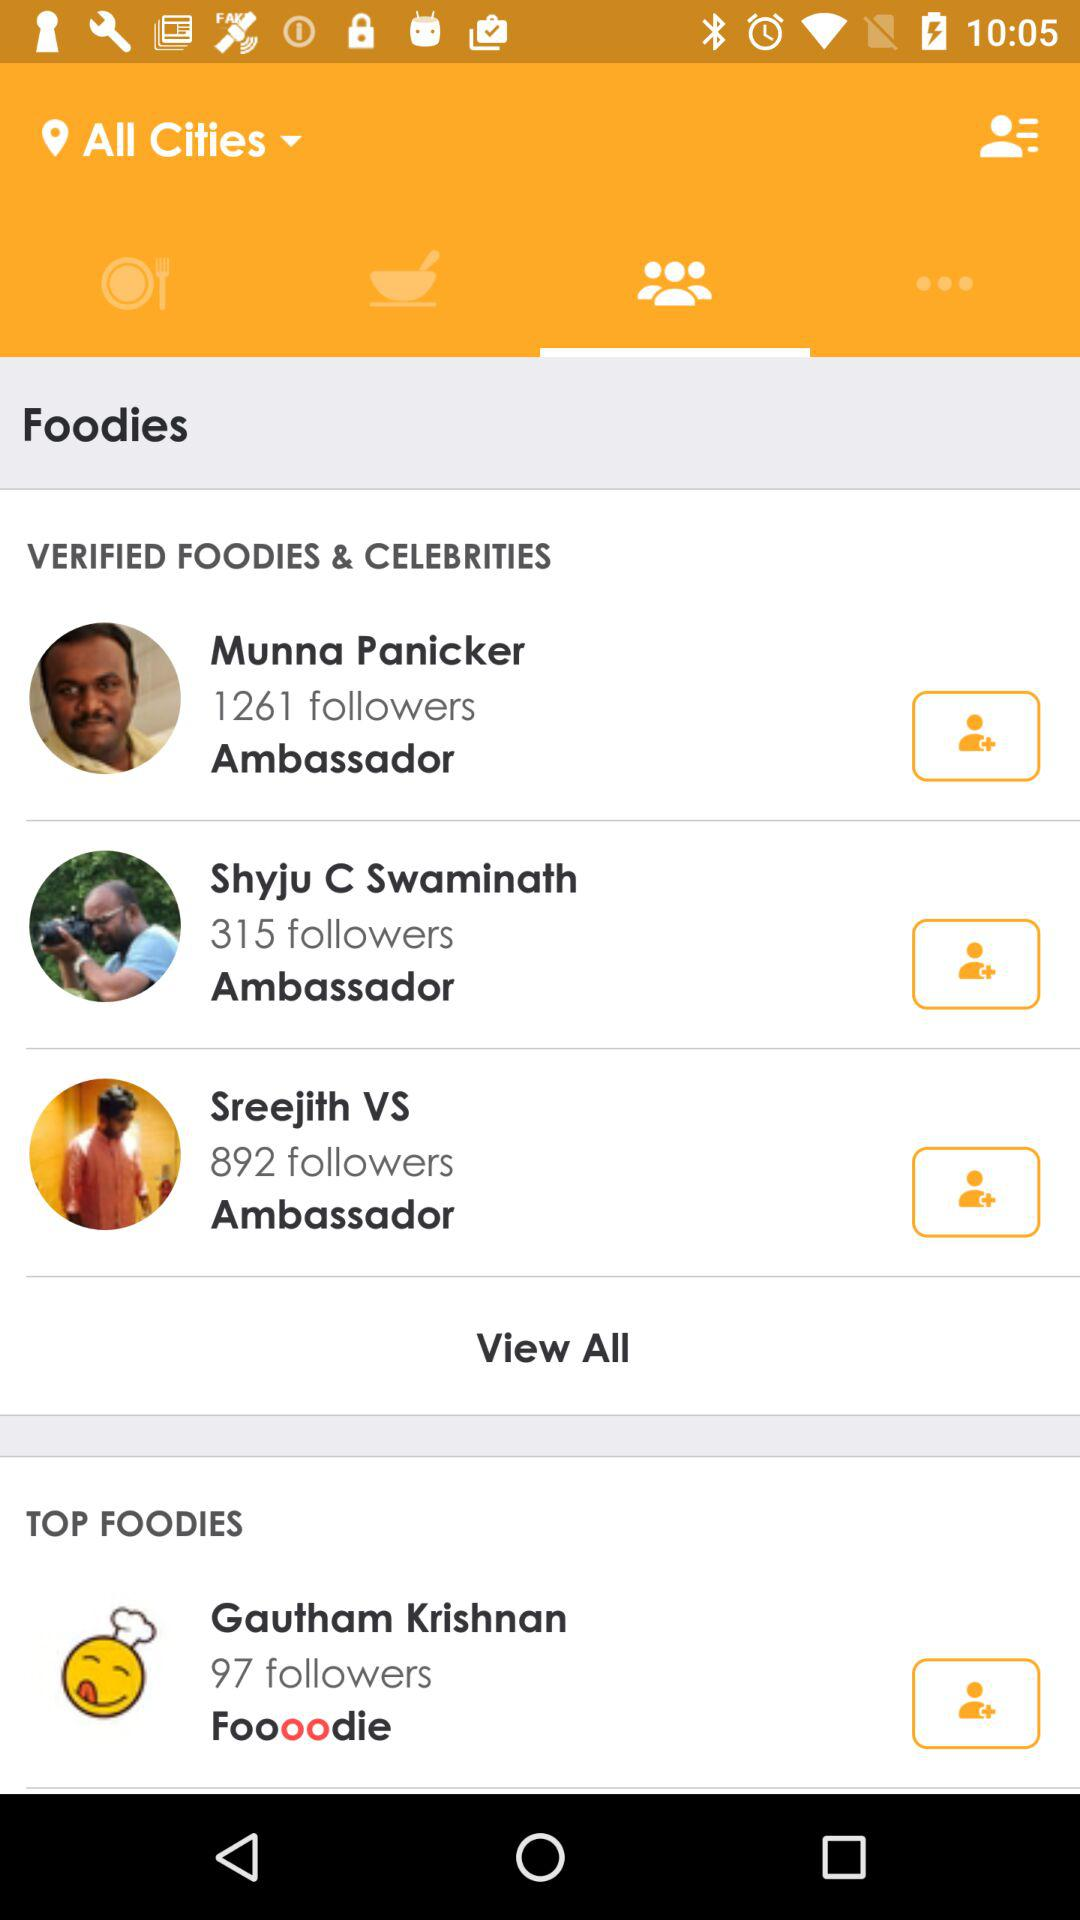How many more followers does Munna Panicker have than Shyju C Swaminath?
Answer the question using a single word or phrase. 946 